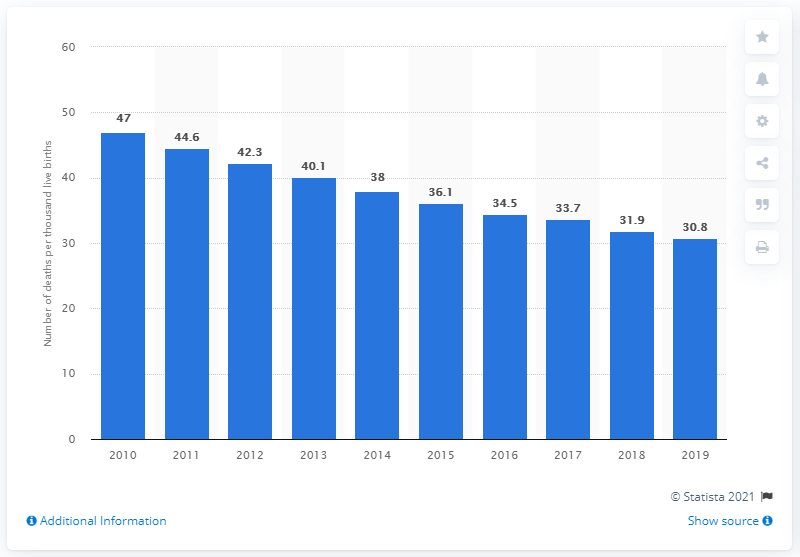Draw attention to some important aspects in this diagram. There have been more than 39,000 live births in each of the past four years. In 2019, the under-five child mortality rate in Nepal was 30.8 deaths per 1,000 live births. In 2014, there were approximately 38,000 live births. 